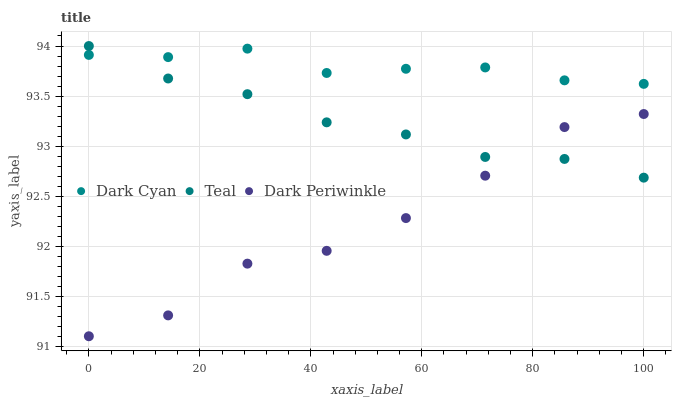Does Dark Periwinkle have the minimum area under the curve?
Answer yes or no. Yes. Does Dark Cyan have the maximum area under the curve?
Answer yes or no. Yes. Does Teal have the minimum area under the curve?
Answer yes or no. No. Does Teal have the maximum area under the curve?
Answer yes or no. No. Is Teal the smoothest?
Answer yes or no. Yes. Is Dark Periwinkle the roughest?
Answer yes or no. Yes. Is Dark Periwinkle the smoothest?
Answer yes or no. No. Is Teal the roughest?
Answer yes or no. No. Does Dark Periwinkle have the lowest value?
Answer yes or no. Yes. Does Teal have the lowest value?
Answer yes or no. No. Does Teal have the highest value?
Answer yes or no. Yes. Does Dark Periwinkle have the highest value?
Answer yes or no. No. Is Dark Periwinkle less than Dark Cyan?
Answer yes or no. Yes. Is Dark Cyan greater than Dark Periwinkle?
Answer yes or no. Yes. Does Dark Cyan intersect Teal?
Answer yes or no. Yes. Is Dark Cyan less than Teal?
Answer yes or no. No. Is Dark Cyan greater than Teal?
Answer yes or no. No. Does Dark Periwinkle intersect Dark Cyan?
Answer yes or no. No. 